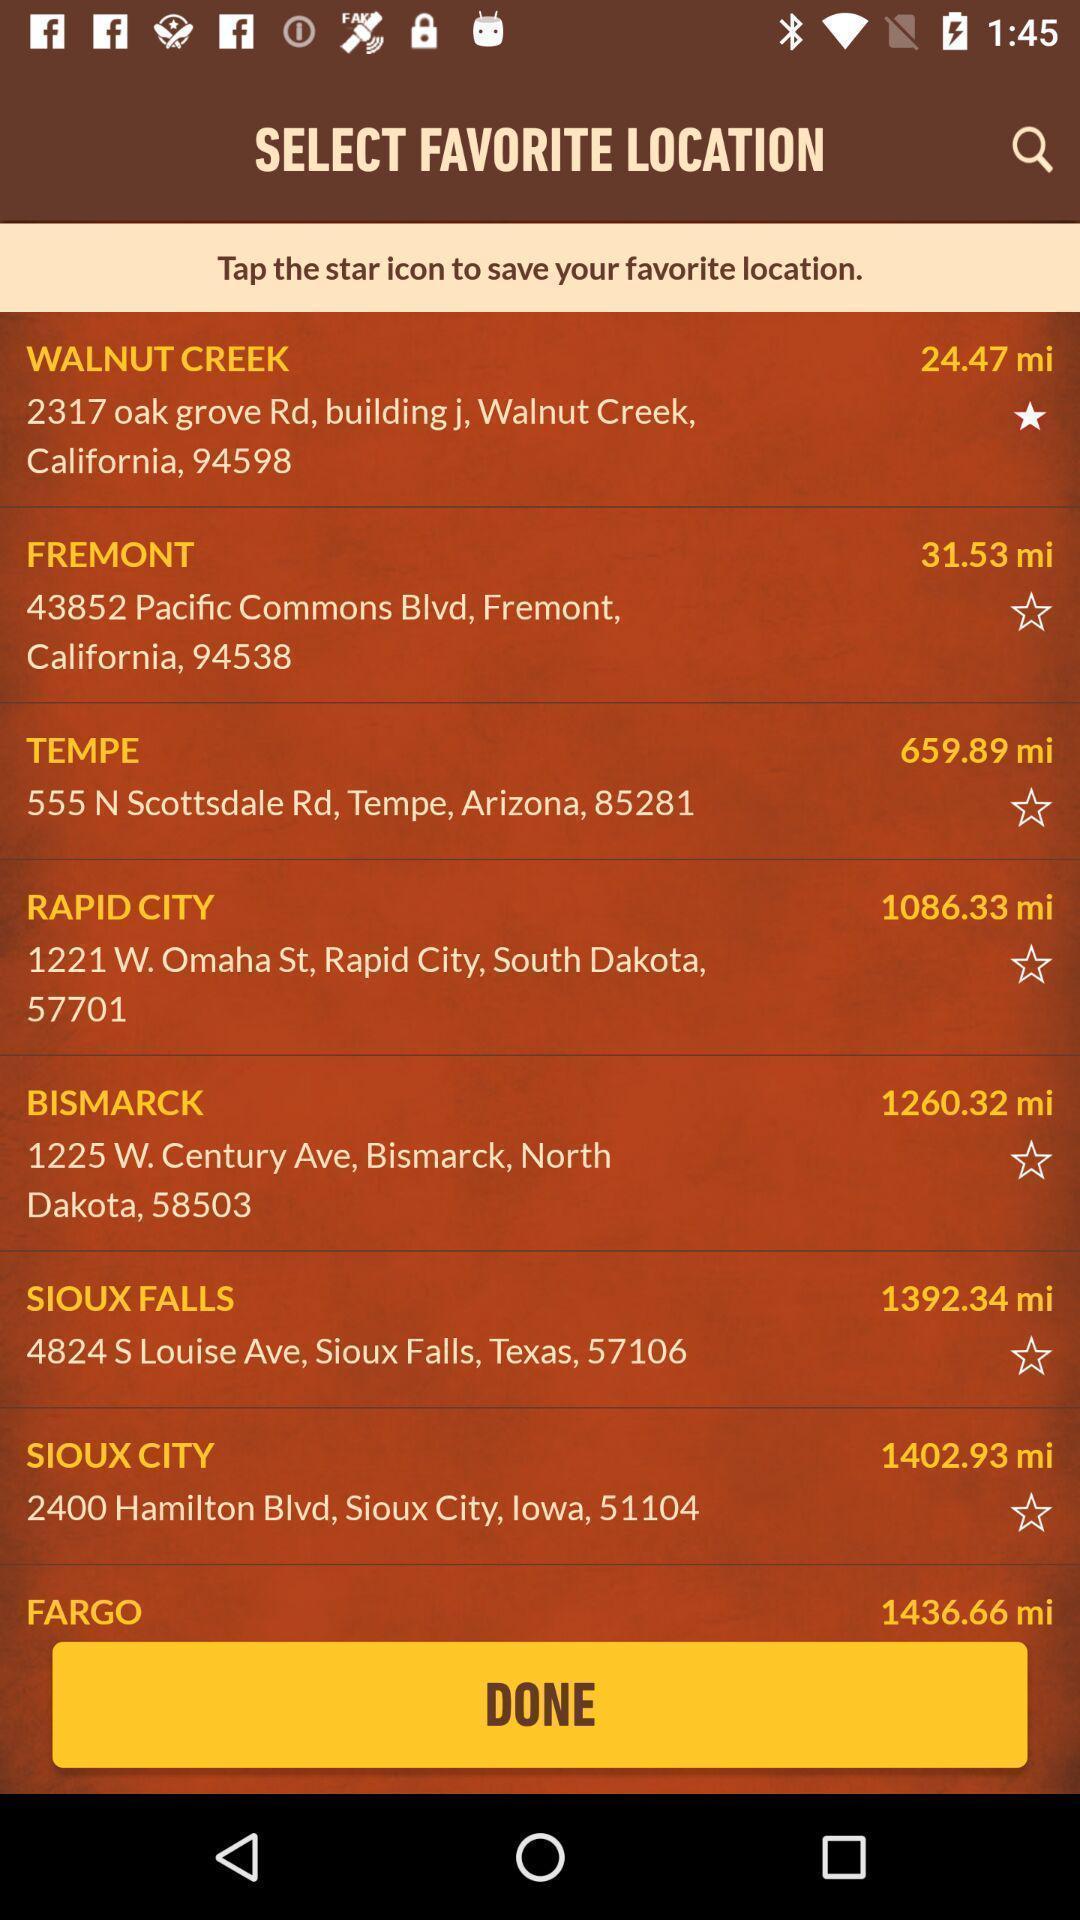Provide a description of this screenshot. Page showing list of different locations. 